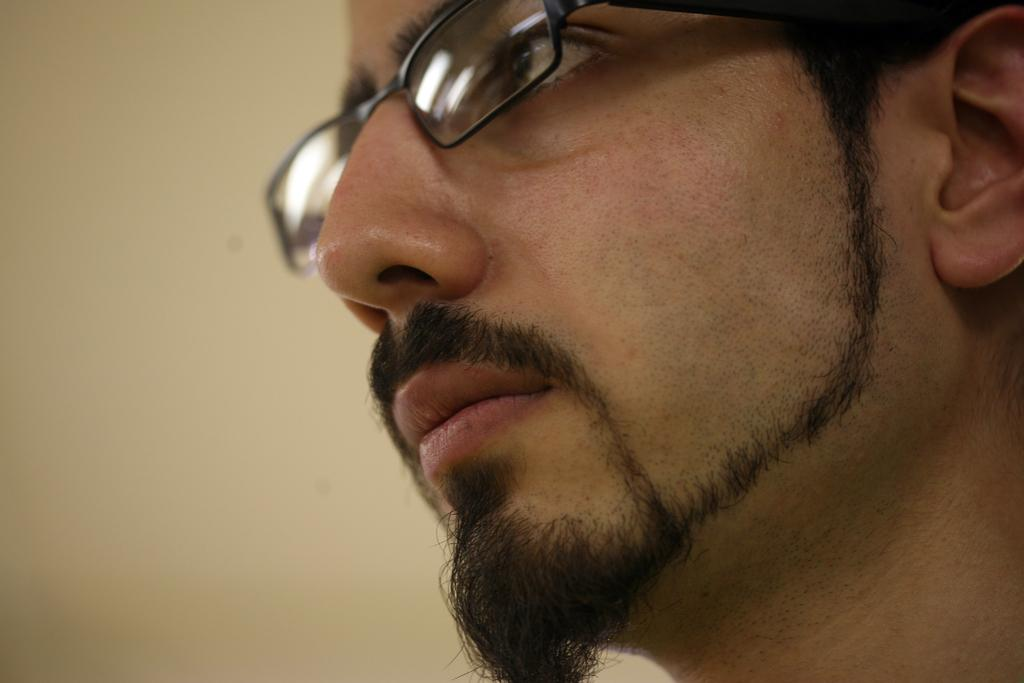Who or what is the main subject of focus of the image? There is a person in the image. Can you describe the person's appearance? The person is wearing spectacles. What can be seen in the background of the image? There is a wall in the background. How many ducks are visible in the image? There are no ducks present in the image. What type of spoon is being used by the person in the image? There is no spoon visible in the image. 